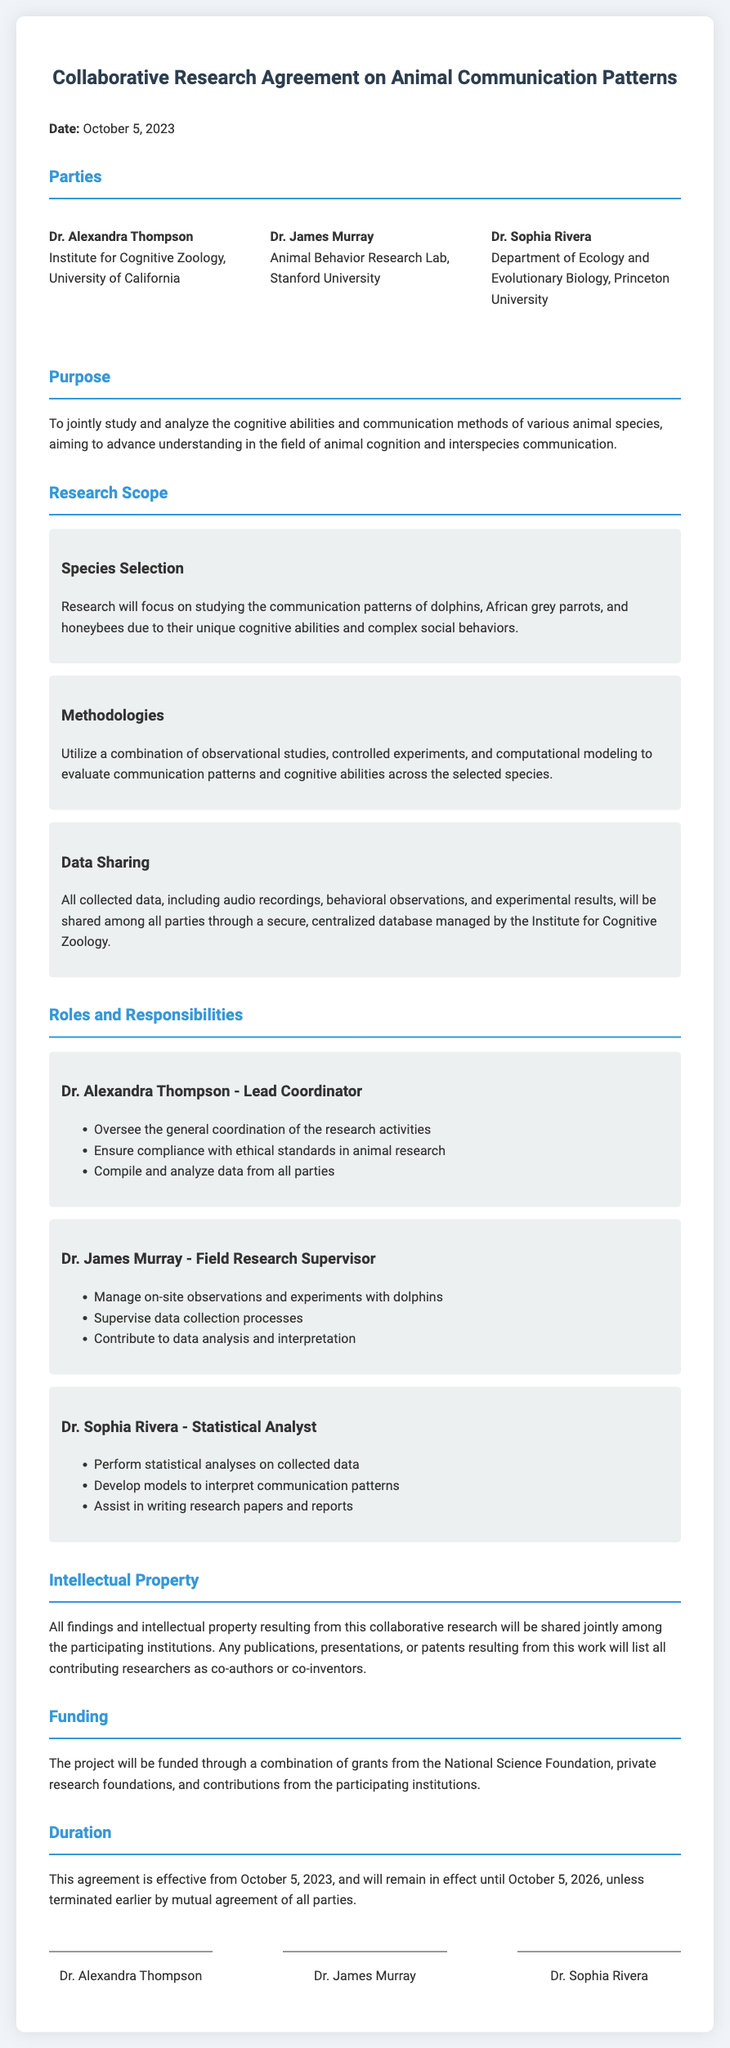What is the date of the agreement? The date of the agreement is clearly stated in the document as October 5, 2023.
Answer: October 5, 2023 Who is the Lead Coordinator? The document specifies Dr. Alexandra Thompson as the Lead Coordinator of the project.
Answer: Dr. Alexandra Thompson What are the three species selected for the research? The research focuses on dolphins, African grey parrots, and honeybees, as mentioned in the scope section.
Answer: Dolphins, African grey parrots, and honeybees What is the duration of the agreement? The agreement is in effect from October 5, 2023, to October 5, 2026, unless terminated earlier.
Answer: October 5, 2026 Which institution manages the centralized database for data sharing? The document reveals that the centralized database will be managed by the Institute for Cognitive Zoology.
Answer: Institute for Cognitive Zoology What role does Dr. James Murray have? Dr. James Murray's role is described as Field Research Supervisor in the roles section.
Answer: Field Research Supervisor How will the funding for the project be sourced? The funding will come from grants, private foundations, and contributions from participating institutions, as stated in the funding section.
Answer: Grants from the National Science Foundation, private research foundations, and contributions What is the primary purpose of the research? The purpose of the research is to study cognitive abilities and communication methods of various animal species, aiming to advance understanding in this field.
Answer: Study cognitive abilities and communication methods of various animal species What happens to the intellectual property resulting from this research? The document states that all findings and intellectual property will be shared jointly among the institutions involved in the research.
Answer: Shared jointly among participating institutions 